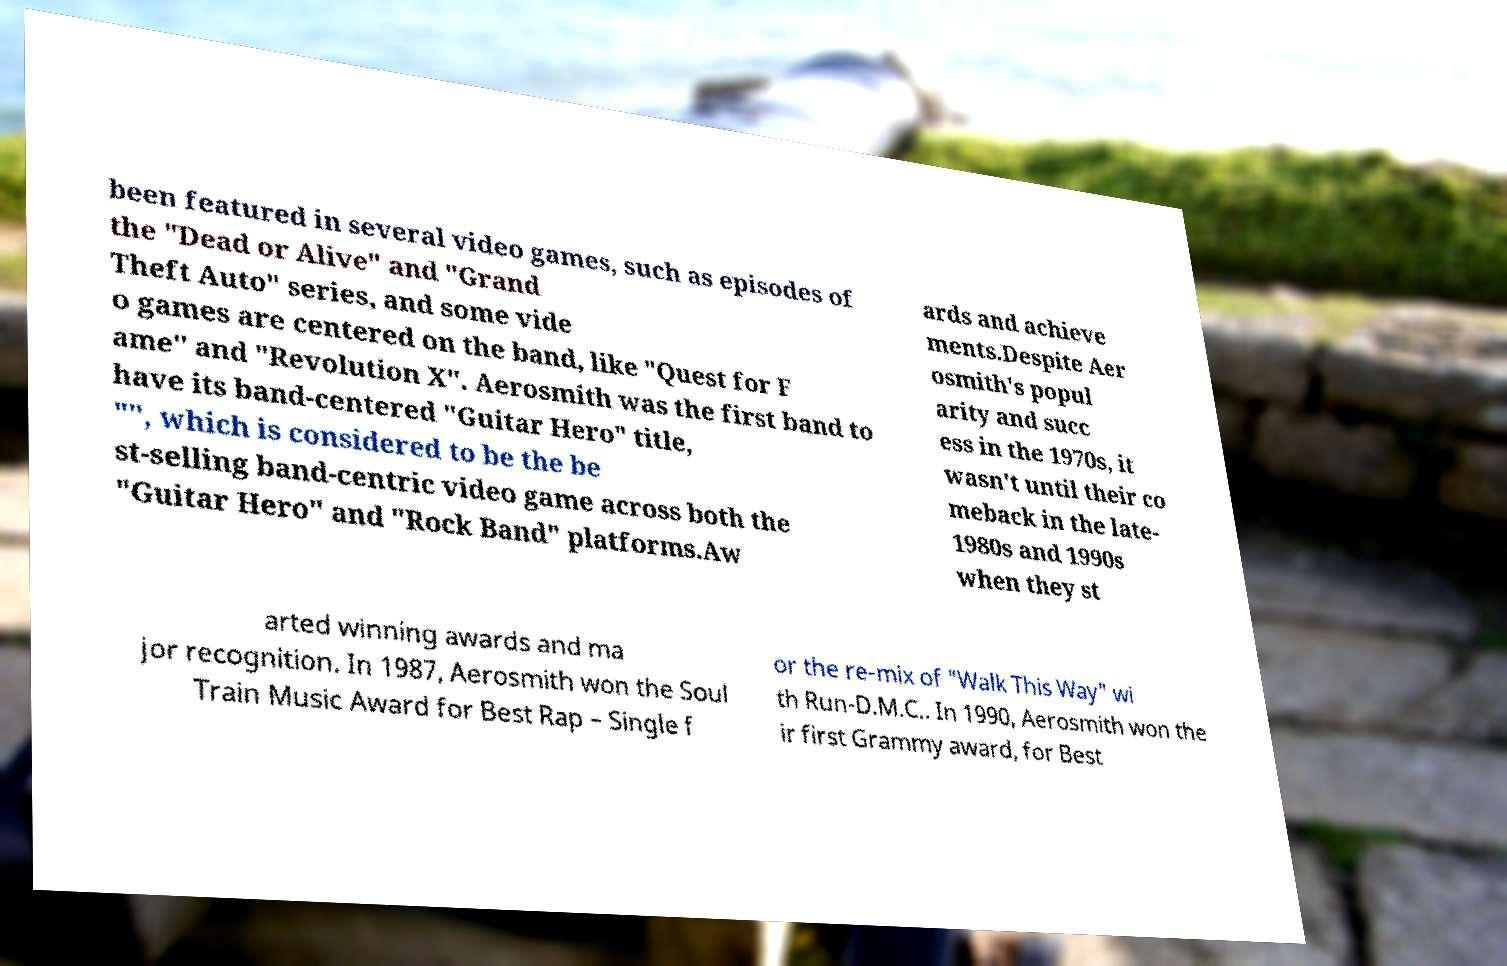Please read and relay the text visible in this image. What does it say? been featured in several video games, such as episodes of the "Dead or Alive" and "Grand Theft Auto" series, and some vide o games are centered on the band, like "Quest for F ame" and "Revolution X". Aerosmith was the first band to have its band-centered "Guitar Hero" title, "", which is considered to be the be st-selling band-centric video game across both the "Guitar Hero" and "Rock Band" platforms.Aw ards and achieve ments.Despite Aer osmith's popul arity and succ ess in the 1970s, it wasn't until their co meback in the late- 1980s and 1990s when they st arted winning awards and ma jor recognition. In 1987, Aerosmith won the Soul Train Music Award for Best Rap – Single f or the re-mix of "Walk This Way" wi th Run-D.M.C.. In 1990, Aerosmith won the ir first Grammy award, for Best 